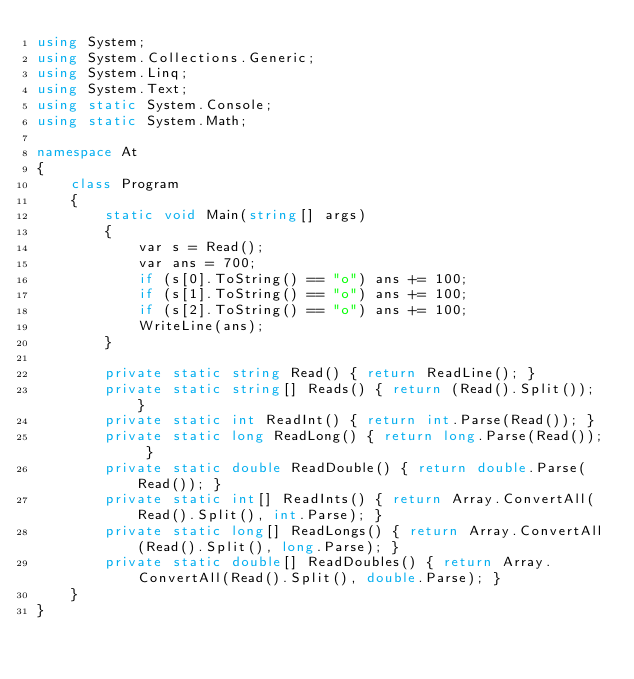Convert code to text. <code><loc_0><loc_0><loc_500><loc_500><_C#_>using System;
using System.Collections.Generic;
using System.Linq;
using System.Text;
using static System.Console;
using static System.Math;

namespace At
{
    class Program
    {
        static void Main(string[] args)
        {
            var s = Read();
            var ans = 700;
            if (s[0].ToString() == "o") ans += 100;
            if (s[1].ToString() == "o") ans += 100;
            if (s[2].ToString() == "o") ans += 100;
            WriteLine(ans);
        }

        private static string Read() { return ReadLine(); }
        private static string[] Reads() { return (Read().Split()); }
        private static int ReadInt() { return int.Parse(Read()); }
        private static long ReadLong() { return long.Parse(Read()); }
        private static double ReadDouble() { return double.Parse(Read()); }
        private static int[] ReadInts() { return Array.ConvertAll(Read().Split(), int.Parse); }
        private static long[] ReadLongs() { return Array.ConvertAll(Read().Split(), long.Parse); }
        private static double[] ReadDoubles() { return Array.ConvertAll(Read().Split(), double.Parse); }
    }
}
</code> 